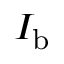<formula> <loc_0><loc_0><loc_500><loc_500>I _ { b }</formula> 